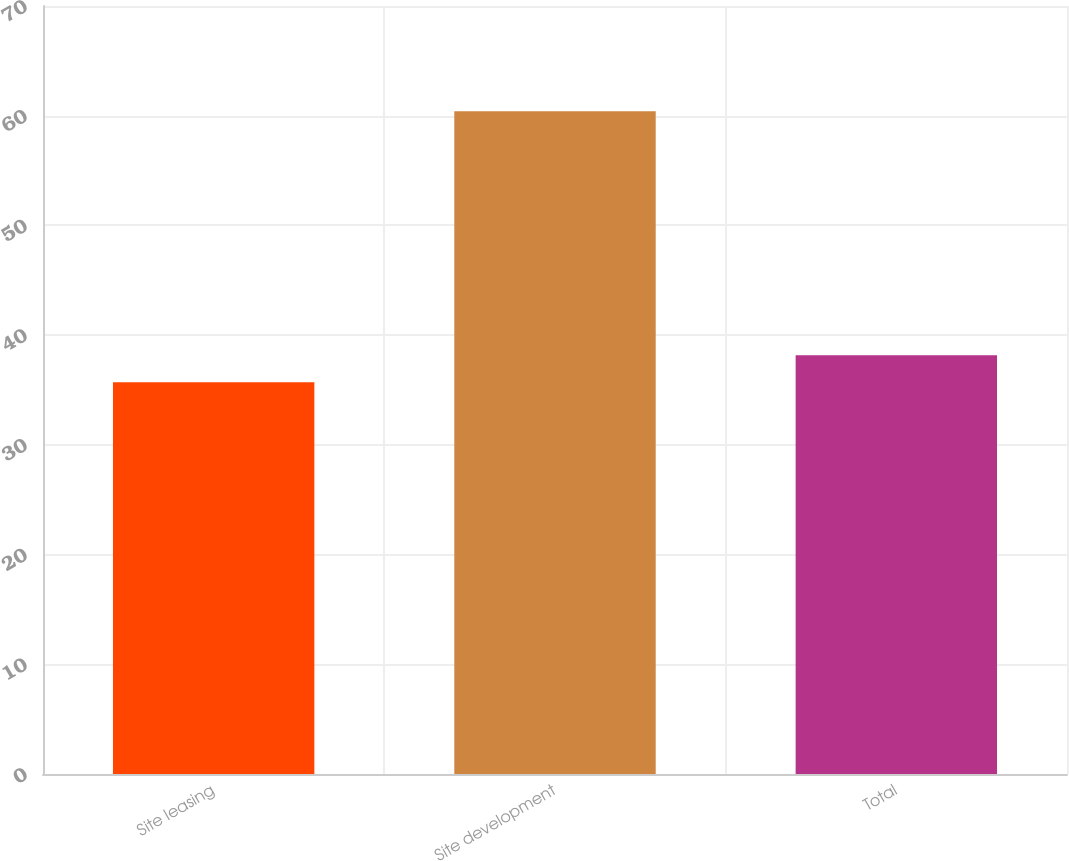<chart> <loc_0><loc_0><loc_500><loc_500><bar_chart><fcel>Site leasing<fcel>Site development<fcel>Total<nl><fcel>35.7<fcel>60.4<fcel>38.17<nl></chart> 